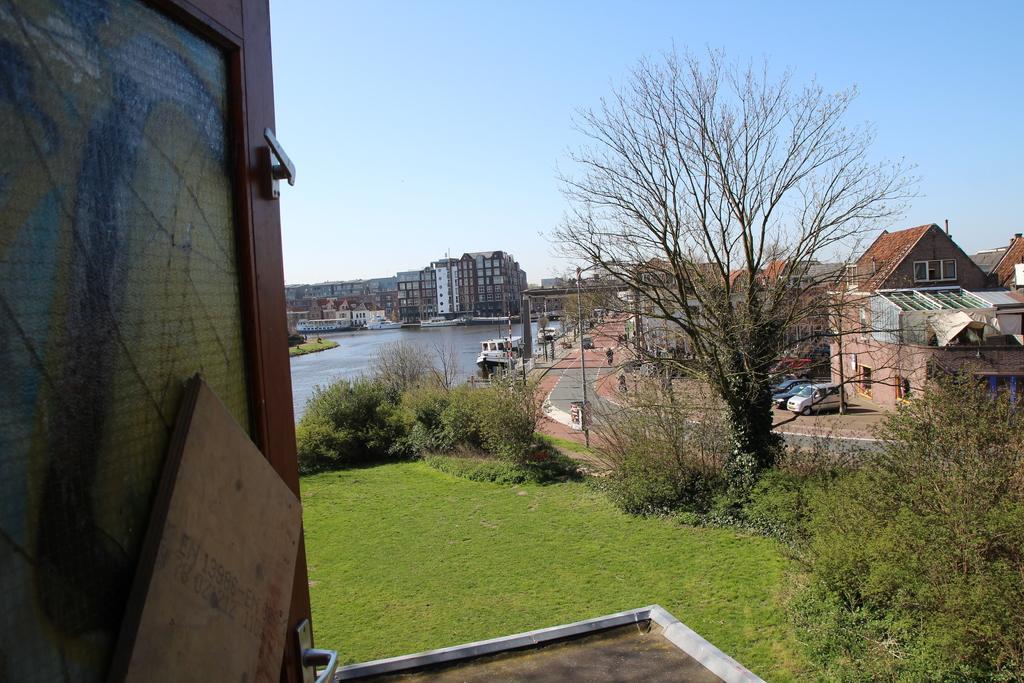Could you give a brief overview of what you see in this image? In this image we can see there is a door, through the door, we can see there are buildings, trees, grass, arch and pole. And there are vehicles on the road. In front of the building there is a ship on the water. At the top there is the sky. 